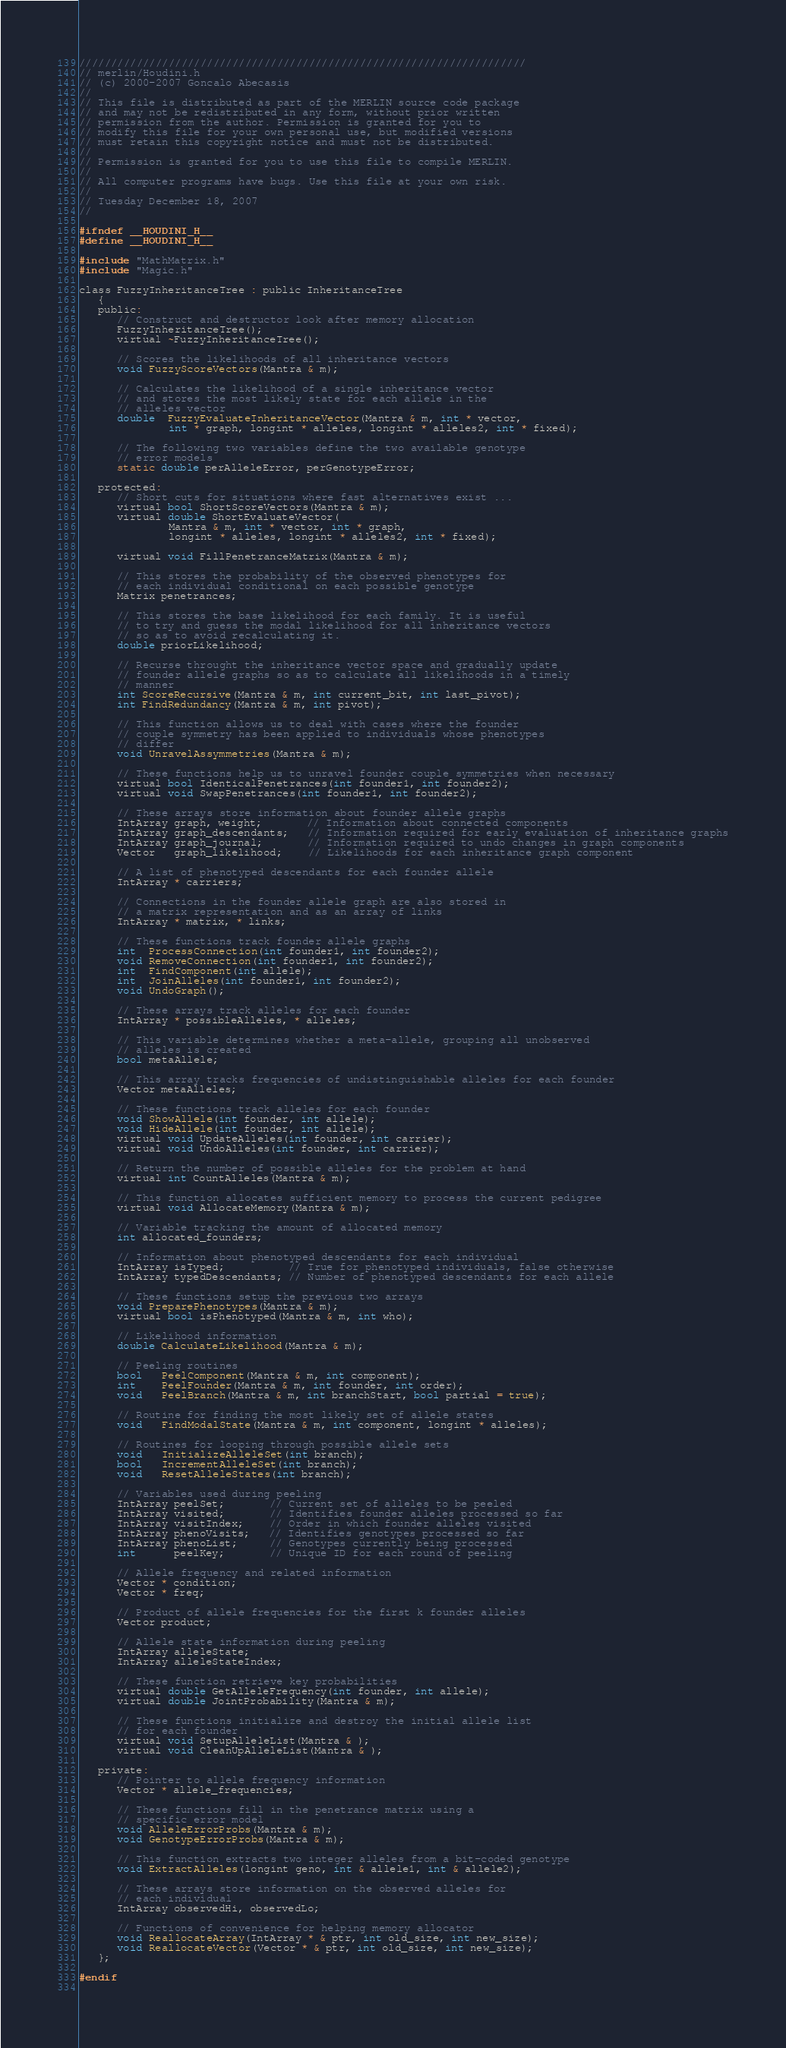<code> <loc_0><loc_0><loc_500><loc_500><_C_>////////////////////////////////////////////////////////////////////// 
// merlin/Houdini.h 
// (c) 2000-2007 Goncalo Abecasis
// 
// This file is distributed as part of the MERLIN source code package   
// and may not be redistributed in any form, without prior written    
// permission from the author. Permission is granted for you to       
// modify this file for your own personal use, but modified versions  
// must retain this copyright notice and must not be distributed.     
// 
// Permission is granted for you to use this file to compile MERLIN.    
// 
// All computer programs have bugs. Use this file at your own risk.   
// 
// Tuesday December 18, 2007
// 
 
#ifndef __HOUDINI_H__
#define __HOUDINI_H__

#include "MathMatrix.h"
#include "Magic.h"

class FuzzyInheritanceTree : public InheritanceTree
   {
   public:
      // Construct and destructor look after memory allocation
      FuzzyInheritanceTree();
      virtual ~FuzzyInheritanceTree();

      // Scores the likelihoods of all inheritance vectors
      void FuzzyScoreVectors(Mantra & m);

      // Calculates the likelihood of a single inheritance vector
      // and stores the most likely state for each allele in the
      // alleles vector
      double  FuzzyEvaluateInheritanceVector(Mantra & m, int * vector,
              int * graph, longint * alleles, longint * alleles2, int * fixed);

      // The following two variables define the two available genotype
      // error models
      static double perAlleleError, perGenotypeError;

   protected:
      // Short cuts for situations where fast alternatives exist ...
      virtual bool ShortScoreVectors(Mantra & m);
      virtual double ShortEvaluateVector(
              Mantra & m, int * vector, int * graph,
              longint * alleles, longint * alleles2, int * fixed);

      virtual void FillPenetranceMatrix(Mantra & m);

      // This stores the probability of the observed phenotypes for
      // each individual conditional on each possible genotype
      Matrix penetrances;

      // This stores the base likelihood for each family. It is useful
      // to try and guess the modal likelihood for all inheritance vectors
      // so as to avoid recalculating it.
      double priorLikelihood;

      // Recurse throught the inheritance vector space and gradually update
      // founder allele graphs so as to calculate all likelihoods in a timely
      // manner
      int ScoreRecursive(Mantra & m, int current_bit, int last_pivot);
      int FindRedundancy(Mantra & m, int pivot);

      // This function allows us to deal with cases where the founder
      // couple symmetry has been applied to individuals whose phenotypes
      // differ
      void UnravelAssymmetries(Mantra & m);

      // These functions help us to unravel founder couple symmetries when necessary
      virtual bool IdenticalPenetrances(int founder1, int founder2);
      virtual void SwapPenetrances(int founder1, int founder2);

      // These arrays store information about founder allele graphs
      IntArray graph, weight;       // Information about connected components
      IntArray graph_descendants;   // Information required for early evaluation of inheritance graphs
      IntArray graph_journal;       // Information required to undo changes in graph components
      Vector   graph_likelihood;    // Likelihoods for each inheritance graph component

      // A list of phenotyped descendants for each founder allele
      IntArray * carriers;

      // Connections in the founder allele graph are also stored in
      // a matrix representation and as an array of links
      IntArray * matrix, * links;

      // These functions track founder allele graphs
      int  ProcessConnection(int founder1, int founder2);
      void RemoveConnection(int founder1, int founder2);
      int  FindComponent(int allele);
      int  JoinAlleles(int founder1, int founder2);
      void UndoGraph();

      // These arrays track alleles for each founder
      IntArray * possibleAlleles, * alleles;

      // This variable determines whether a meta-allele, grouping all unobserved
      // alleles is created
      bool metaAllele;

      // This array tracks frequencies of undistinguishable alleles for each founder
      Vector metaAlleles;

      // These functions track alleles for each founder
      void ShowAllele(int founder, int allele);
      void HideAllele(int founder, int allele);
      virtual void UpdateAlleles(int founder, int carrier);
      virtual void UndoAlleles(int founder, int carrier);

      // Return the number of possible alleles for the problem at hand
      virtual int CountAlleles(Mantra & m);

      // This function allocates sufficient memory to process the current pedigree
      virtual void AllocateMemory(Mantra & m);

      // Variable tracking the amount of allocated memory
      int allocated_founders;

      // Information about phenotyped descendants for each individual
      IntArray isTyped;          // True for phenotyped individuals, false otherwise
      IntArray typedDescendants; // Number of phenotyped descendants for each allele

      // These functions setup the previous two arrays
      void PreparePhenotypes(Mantra & m);
      virtual bool isPhenotyped(Mantra & m, int who);

      // Likelihood information
      double CalculateLikelihood(Mantra & m);

      // Peeling routines
      bool   PeelComponent(Mantra & m, int component);
      int    PeelFounder(Mantra & m, int founder, int order);
      void   PeelBranch(Mantra & m, int branchStart, bool partial = true);

      // Routine for finding the most likely set of allele states
      void   FindModalState(Mantra & m, int component, longint * alleles);

      // Routines for looping through possible allele sets
      void   InitializeAlleleSet(int branch);
      bool   IncrementAlleleSet(int branch);
      void   ResetAlleleStates(int branch);

      // Variables used during peeling
      IntArray peelSet;       // Current set of alleles to be peeled
      IntArray visited;       // Identifies founder alleles processed so far
      IntArray visitIndex;    // Order in which founder alleles visited
      IntArray phenoVisits;   // Identifies genotypes processed so far
      IntArray phenoList;     // Genotypes currently being processed
      int      peelKey;       // Unique ID for each round of peeling

      // Allele frequency and related information
      Vector * condition;
      Vector * freq;

      // Product of allele frequencies for the first k founder alleles
      Vector product;

      // Allele state information during peeling
      IntArray alleleState;
      IntArray alleleStateIndex;

      // These function retrieve key probabilities
      virtual double GetAlleleFrequency(int founder, int allele);
      virtual double JointProbability(Mantra & m);

      // These functions initialize and destroy the initial allele list
      // for each founder
      virtual void SetupAlleleList(Mantra & );
      virtual void CleanUpAlleleList(Mantra & );

   private:
      // Pointer to allele frequency information
      Vector * allele_frequencies;

      // These functions fill in the penetrance matrix using a
      // specific error model
      void AlleleErrorProbs(Mantra & m);
      void GenotypeErrorProbs(Mantra & m);

      // This function extracts two integer alleles from a bit-coded genotype
      void ExtractAlleles(longint geno, int & allele1, int & allele2);

      // These arrays store information on the observed alleles for
      // each individual
      IntArray observedHi, observedLo;

      // Functions of convenience for helping memory allocator
      void ReallocateArray(IntArray * & ptr, int old_size, int new_size);
      void ReallocateVector(Vector * & ptr, int old_size, int new_size);
   };

#endif
 
</code> 